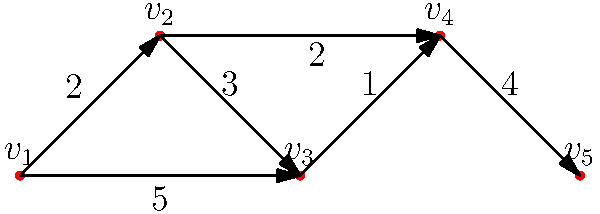In our distribution center's conveyor belt system, represented by the directed graph above, each vertex ($v_1$ to $v_5$) represents a sorting station, and each edge represents a conveyor belt with its weight indicating the time (in minutes) for a package to travel between stations. What is the minimum time required for a package to travel from station $v_1$ to station $v_5$? To find the minimum time for a package to travel from $v_1$ to $v_5$, we need to identify the shortest path between these two vertices. Let's examine all possible paths:

1. Path 1: $v_1 \rightarrow v_2 \rightarrow v_3 \rightarrow v_4 \rightarrow v_5$
   Time = $2 + 3 + 1 + 4 = 10$ minutes

2. Path 2: $v_1 \rightarrow v_2 \rightarrow v_4 \rightarrow v_5$
   Time = $2 + 2 + 4 = 8$ minutes

3. Path 3: $v_1 \rightarrow v_3 \rightarrow v_4 \rightarrow v_5$
   Time = $5 + 1 + 4 = 10$ minutes

The shortest path is Path 2, which takes 8 minutes. This path utilizes the shortcut from $v_2$ to $v_4$, bypassing $v_3$ and saving time.

This analysis helps us understand the most efficient route for package sorting, which is crucial for maximizing the distribution center's efficiency and ensuring timely delivery of packages.
Answer: 8 minutes 